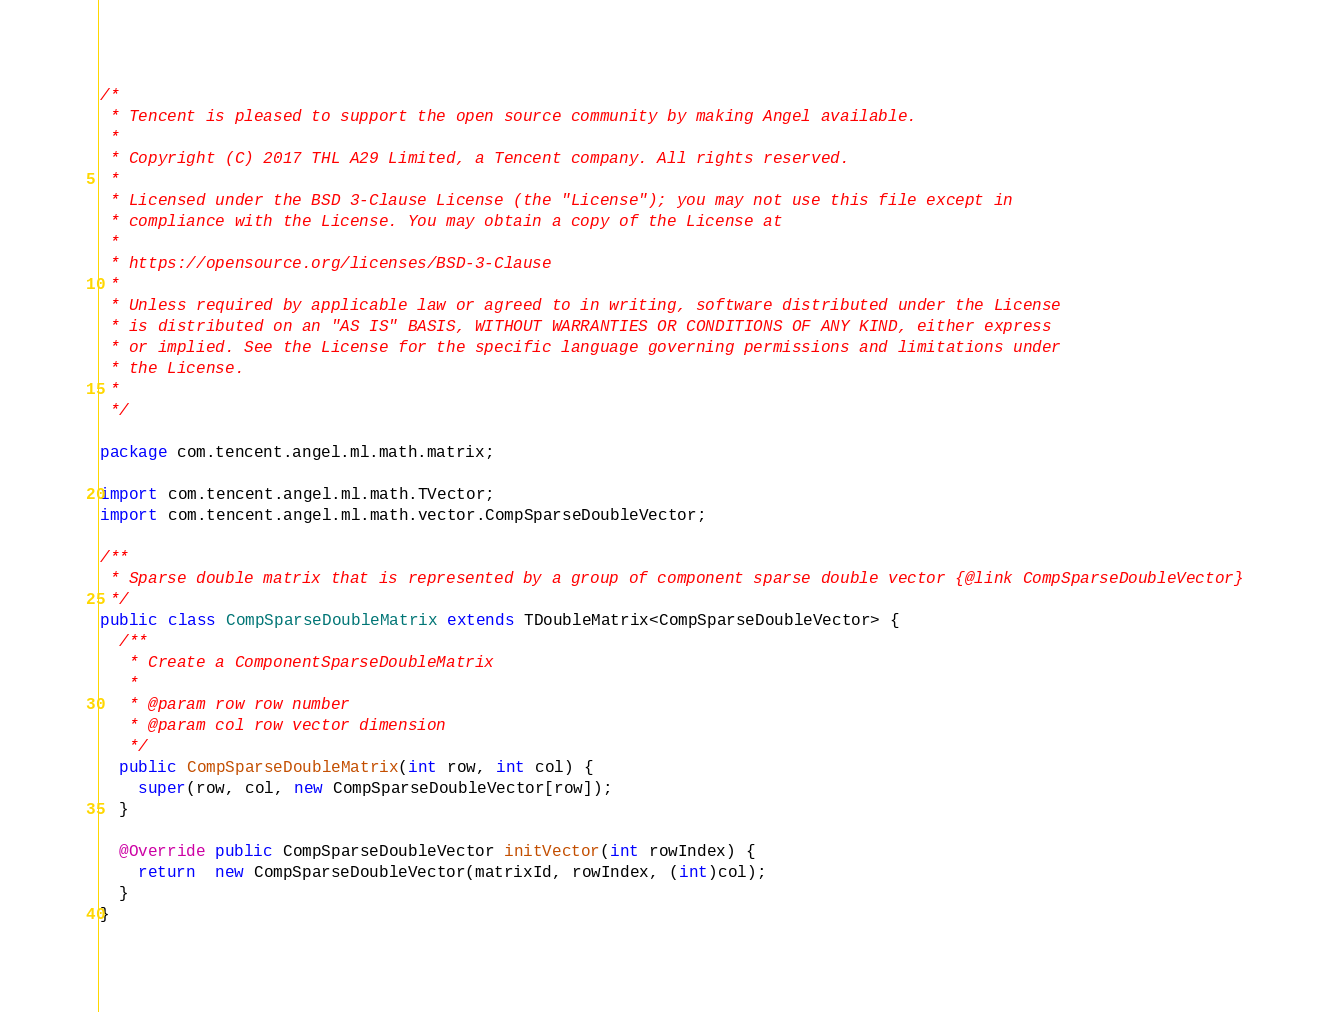Convert code to text. <code><loc_0><loc_0><loc_500><loc_500><_Java_>/*
 * Tencent is pleased to support the open source community by making Angel available.
 *
 * Copyright (C) 2017 THL A29 Limited, a Tencent company. All rights reserved.
 *
 * Licensed under the BSD 3-Clause License (the "License"); you may not use this file except in
 * compliance with the License. You may obtain a copy of the License at
 *
 * https://opensource.org/licenses/BSD-3-Clause
 *
 * Unless required by applicable law or agreed to in writing, software distributed under the License
 * is distributed on an "AS IS" BASIS, WITHOUT WARRANTIES OR CONDITIONS OF ANY KIND, either express
 * or implied. See the License for the specific language governing permissions and limitations under
 * the License.
 *
 */

package com.tencent.angel.ml.math.matrix;

import com.tencent.angel.ml.math.TVector;
import com.tencent.angel.ml.math.vector.CompSparseDoubleVector;

/**
 * Sparse double matrix that is represented by a group of component sparse double vector {@link CompSparseDoubleVector}
 */
public class CompSparseDoubleMatrix extends TDoubleMatrix<CompSparseDoubleVector> {
  /**
   * Create a ComponentSparseDoubleMatrix
   *
   * @param row row number
   * @param col row vector dimension
   */
  public CompSparseDoubleMatrix(int row, int col) {
    super(row, col, new CompSparseDoubleVector[row]);
  }

  @Override public CompSparseDoubleVector initVector(int rowIndex) {
    return  new CompSparseDoubleVector(matrixId, rowIndex, (int)col);
  }
}
</code> 